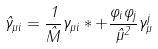<formula> <loc_0><loc_0><loc_500><loc_500>\hat { \gamma } _ { \mu i } = \frac { 1 } { \hat { M } } { \gamma } _ { \mu i } \ast + \frac { \varphi _ { i } \varphi _ { j } } { \hat { \mu } ^ { 2 } } \gamma ^ { j } _ { \mu }</formula> 